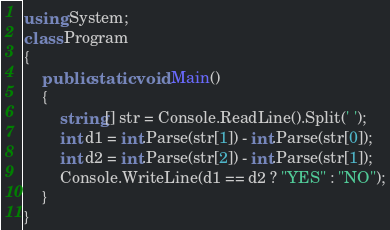<code> <loc_0><loc_0><loc_500><loc_500><_C#_>using System;
class Program
{
    public static void Main()
    {
        string[] str = Console.ReadLine().Split(' ');
        int d1 = int.Parse(str[1]) - int.Parse(str[0]);
        int d2 = int.Parse(str[2]) - int.Parse(str[1]);
        Console.WriteLine(d1 == d2 ? "YES" : "NO");
    }
}</code> 